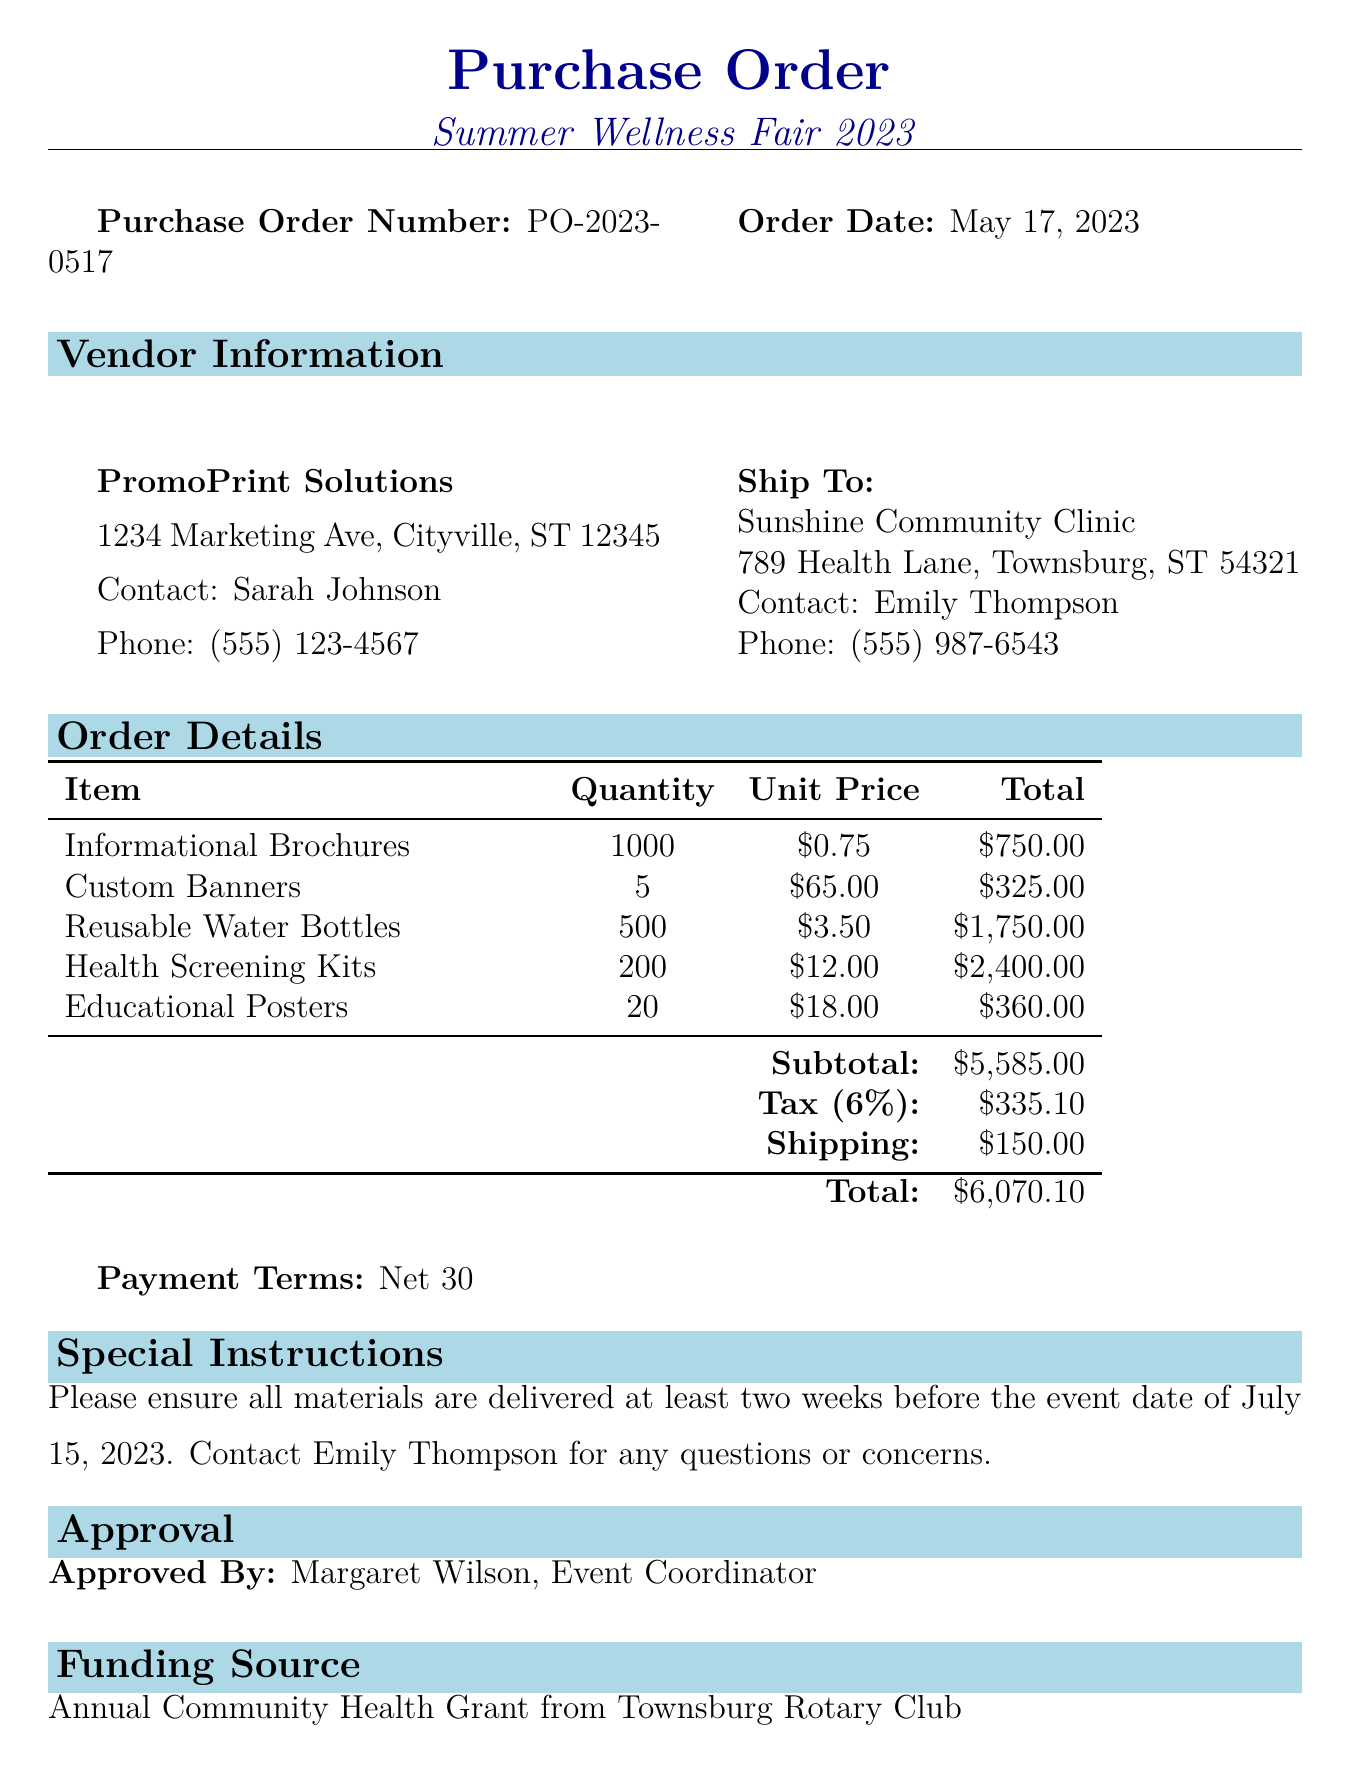what is the purchase order number? The purchase order number is prominently listed in the document for easy reference.
Answer: PO-2023-0517 who is the vendor for this purchase order? The vendor's name is stated clearly in the document, identifying who is providing the materials.
Answer: PromoPrint Solutions what is the total amount of the order? The total amount is calculated after including the subtotal, tax, and shipping costs.
Answer: $6070.10 how many reusable water bottles are ordered? The quantity for reusable water bottles is specified in the items section of the document.
Answer: 500 what are the payment terms for this order? The payment terms indicate when the payment is due after receiving the invoice.
Answer: Net 30 which campaign is this purchase order for? The campaign name is explicitly stated to show the purpose of the order.
Answer: Summer Wellness Fair 2023 who approved this purchase order? The approval section identifies the person responsible for authorizing the order.
Answer: Margaret Wilson, Event Coordinator what is the special instruction regarding delivery? Special instructions guide the vendor on the delivery requirements to ensure timely arrival of materials.
Answer: Please ensure all materials are delivered at least two weeks before the event date of July 15, 2023 what is the shipping address? The shipping address is important for confirming where the materials need to be sent.
Answer: Sunshine Community Clinic, 789 Health Lane, Townsburg, ST 54321 